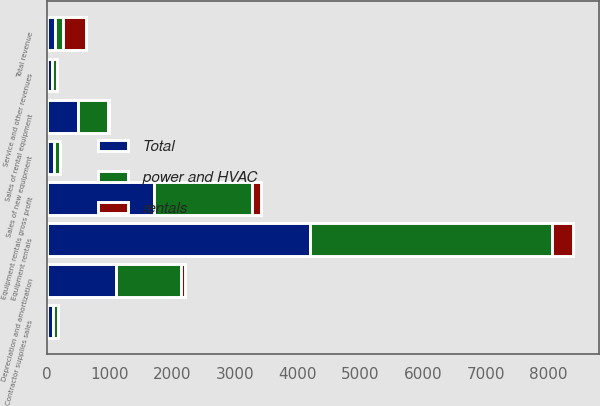Convert chart. <chart><loc_0><loc_0><loc_500><loc_500><stacked_bar_chart><ecel><fcel>Equipment rentals<fcel>Sales of rental equipment<fcel>Sales of new equipment<fcel>Contractor supplies sales<fcel>Service and other revenues<fcel>Total revenue<fcel>Depreciation and amortization<fcel>Equipment rentals gross profit<nl><fcel>power and HVAC<fcel>3869<fcel>474<fcel>97<fcel>79<fcel>72<fcel>128.5<fcel>1038<fcel>1557<nl><fcel>rentals<fcel>327<fcel>16<fcel>7<fcel>8<fcel>6<fcel>364<fcel>60<fcel>153<nl><fcel>Total<fcel>4196<fcel>490<fcel>104<fcel>87<fcel>78<fcel>128.5<fcel>1098<fcel>1710<nl></chart> 